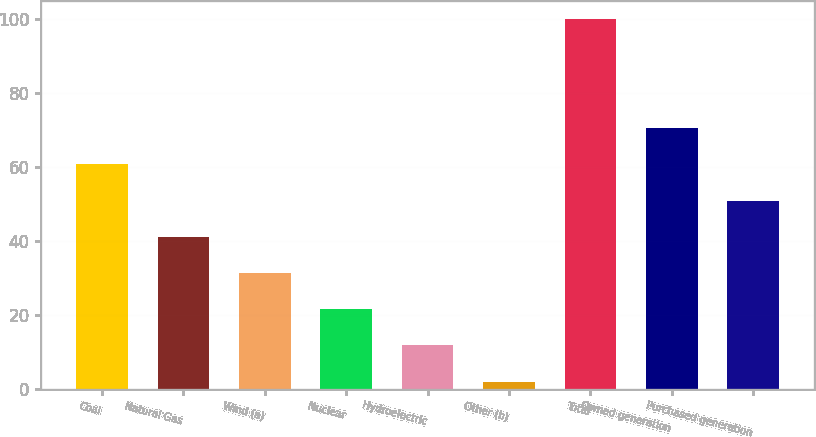<chart> <loc_0><loc_0><loc_500><loc_500><bar_chart><fcel>Coal<fcel>Natural Gas<fcel>Wind (a)<fcel>Nuclear<fcel>Hydroelectric<fcel>Other (b)<fcel>Total<fcel>Owned generation<fcel>Purchased generation<nl><fcel>60.8<fcel>41.2<fcel>31.4<fcel>21.6<fcel>11.8<fcel>2<fcel>100<fcel>70.6<fcel>51<nl></chart> 